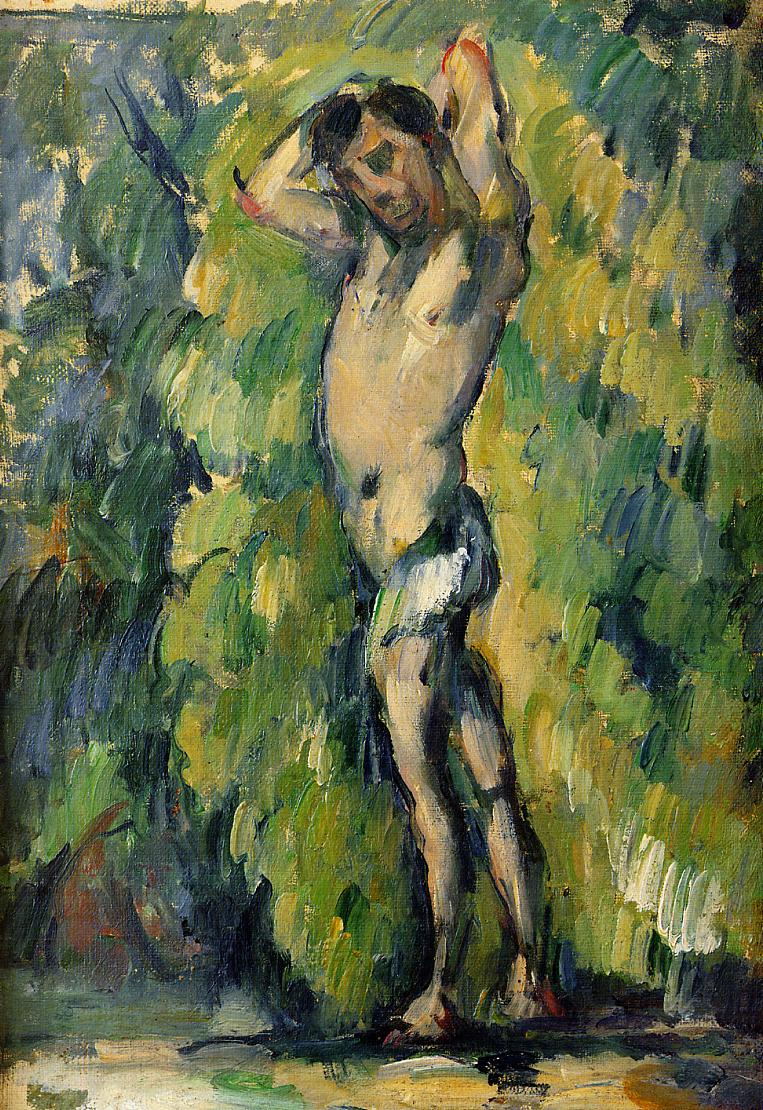What time of day or season does this painting represent? The use of bright, luminous greens and the presence of shadows suggest a setting bathed in natural daylight. The light appears to be dappled, as though filtered through leaves, which could indicate a scene set in the late morning or early afternoon. There's an overall freshness to the scene that might hint at spring or summer as the season depicted. 